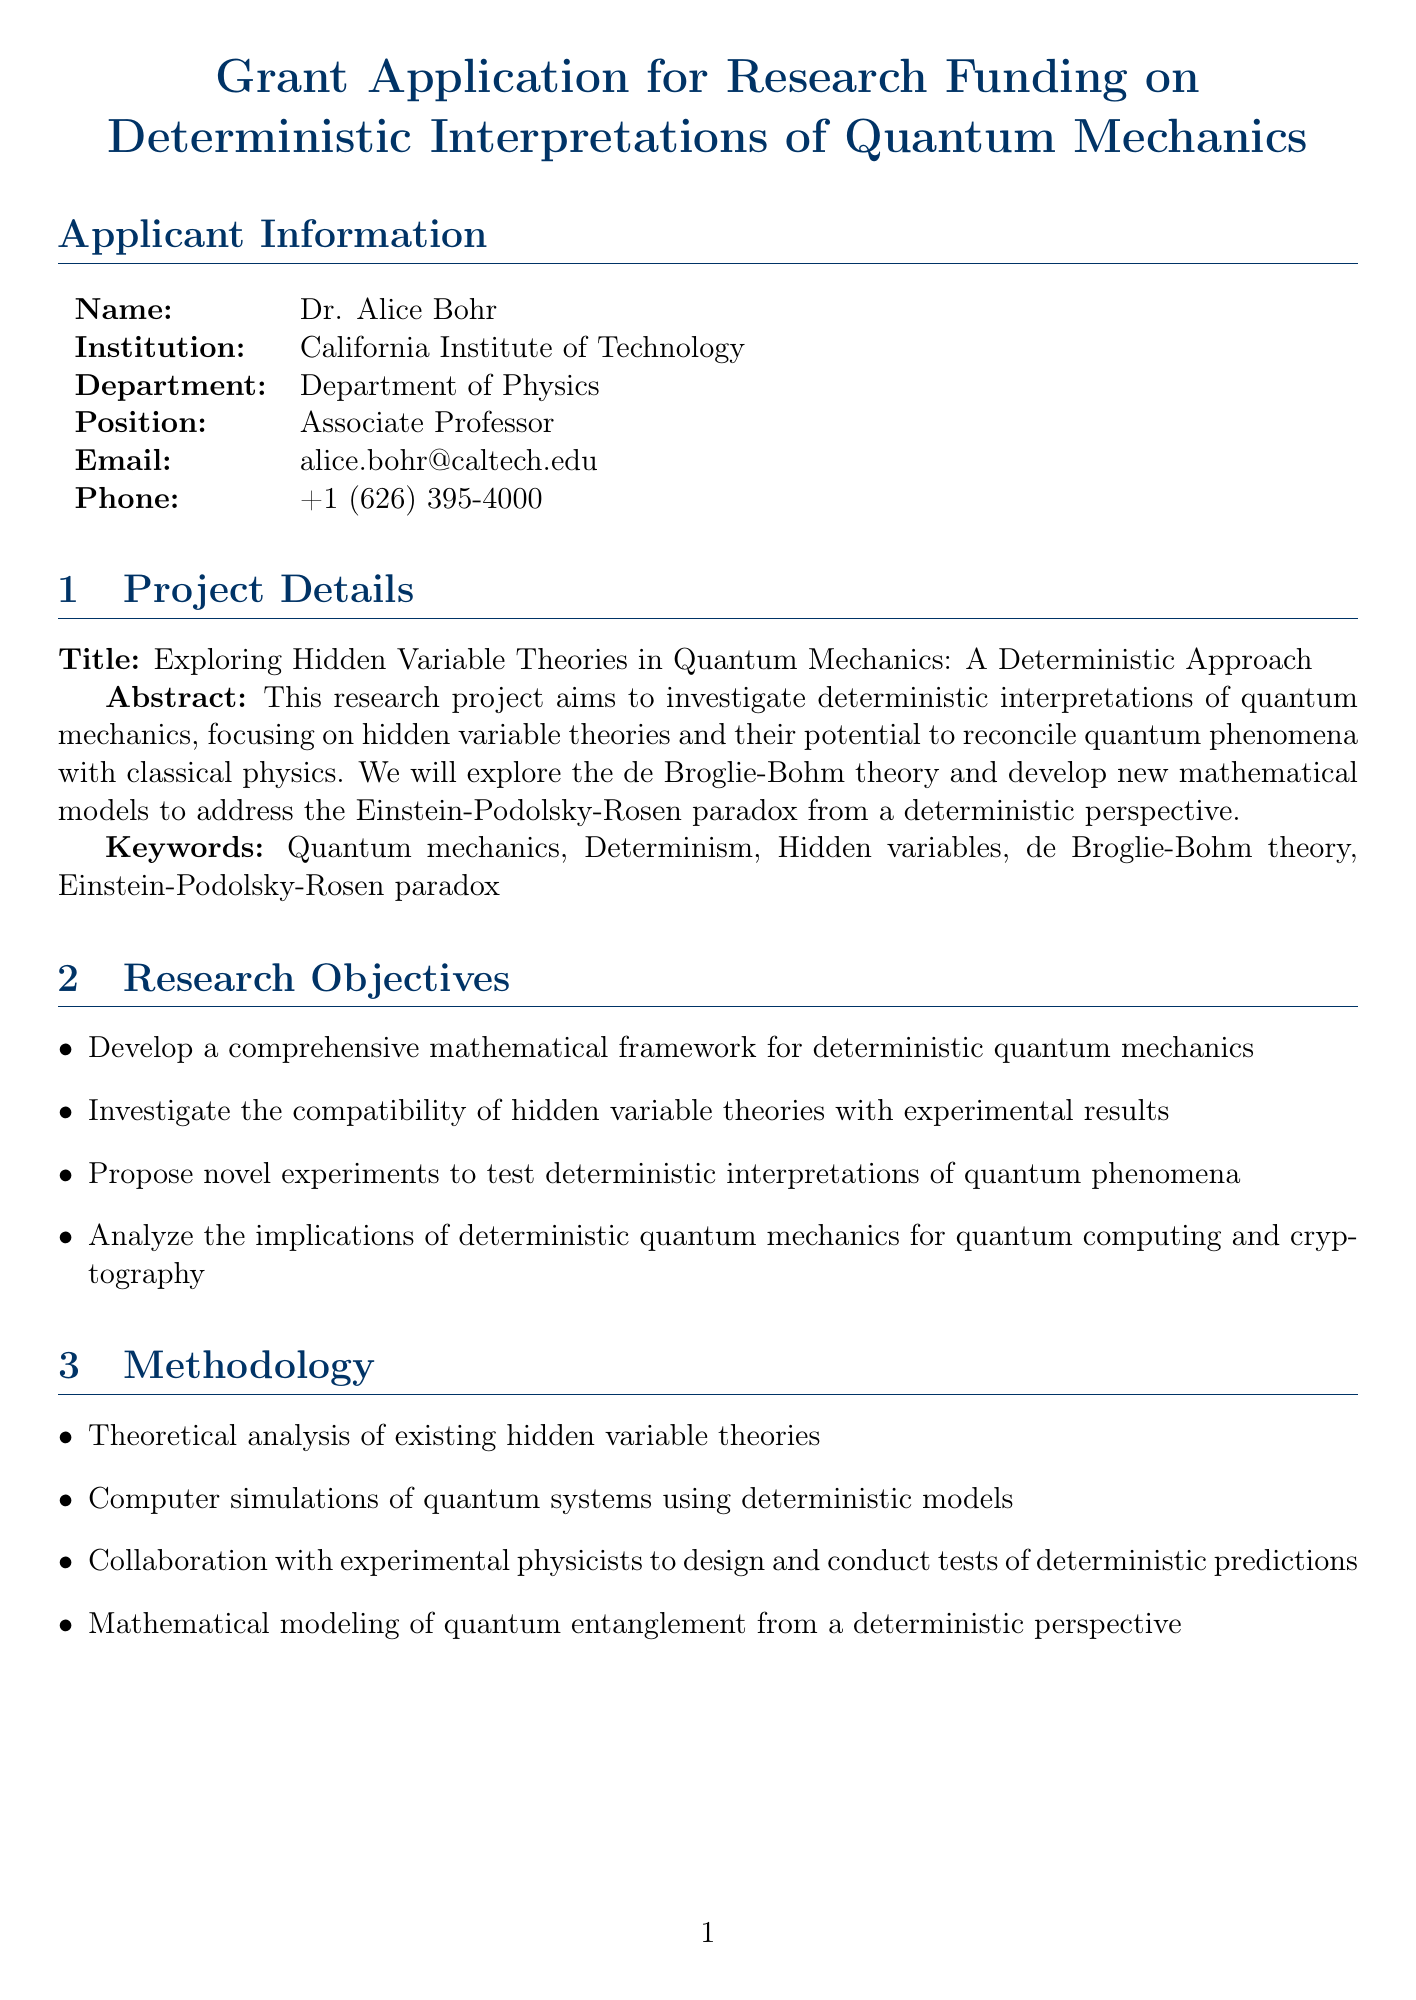what is the name of the principal investigator? The principal investigator is mentioned in the applicant information section of the document as Dr. Alice Bohr.
Answer: Dr. Alice Bohr what is the total budget for the project? The total budget is listed in the budget breakdown section of the document, totaling 530,000 dollars.
Answer: 530,000 what is the duration of the literature review phase? The duration of the literature review phase is provided in the timeline section as 6 months.
Answer: 6 months who is the theoretical physics consultant collaborating on the project? The collaborator section lists the theoretical physics consultant as Dr. David Deutsch.
Answer: Dr. David Deutsch when does the experimental design phase start? The start date for the experimental design and collaboration phase is indicated in the timeline section as November 1, 2024.
Answer: November 1, 2024 what is one expected outcome of the project? The expected outcomes section mentions that one expected outcome is the formulation of a new mathematical framework for deterministic quantum mechanics.
Answer: A new mathematical framework for deterministic quantum mechanics how long will the publication phase last? The duration of the publication and dissemination of results phase is mentioned in the timeline section as 4 months.
Answer: 4 months what is the email address of the principal investigator? The email address of the principal investigator is specified in the applicant information section as alice.bohr@caltech.edu.
Answer: alice.bohr@caltech.edu what are the three categories of personnel costs? The budget breakdown specifies three personnel categories: principal investigator, postdoctoral researcher, and graduate students.
Answer: Principal investigator, postdoctoral researcher, graduate students 